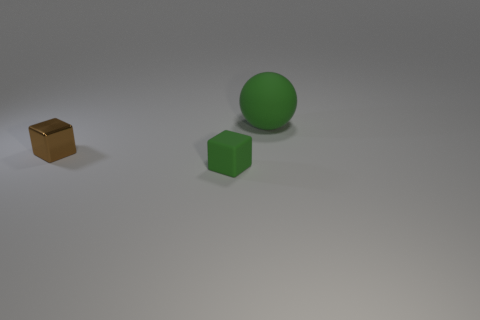There is a green object that is in front of the large ball; is its size the same as the thing that is right of the tiny green block?
Your answer should be very brief. No. What number of things are objects behind the brown thing or green objects behind the metallic object?
Give a very brief answer. 1. Are there any green objects in front of the green rubber thing that is behind the matte cube?
Ensure brevity in your answer.  Yes. There is a green object that is the same size as the brown cube; what is its shape?
Offer a terse response. Cube. How many things are brown shiny things that are in front of the big rubber ball or brown cubes?
Offer a terse response. 1. What number of other things are the same material as the tiny green thing?
Provide a succinct answer. 1. The thing that is the same color as the large matte ball is what shape?
Your answer should be compact. Cube. How big is the green matte object in front of the rubber ball?
Give a very brief answer. Small. What is the shape of the other green thing that is the same material as the large green thing?
Offer a terse response. Cube. Are the small green block and the block behind the green matte block made of the same material?
Ensure brevity in your answer.  No. 